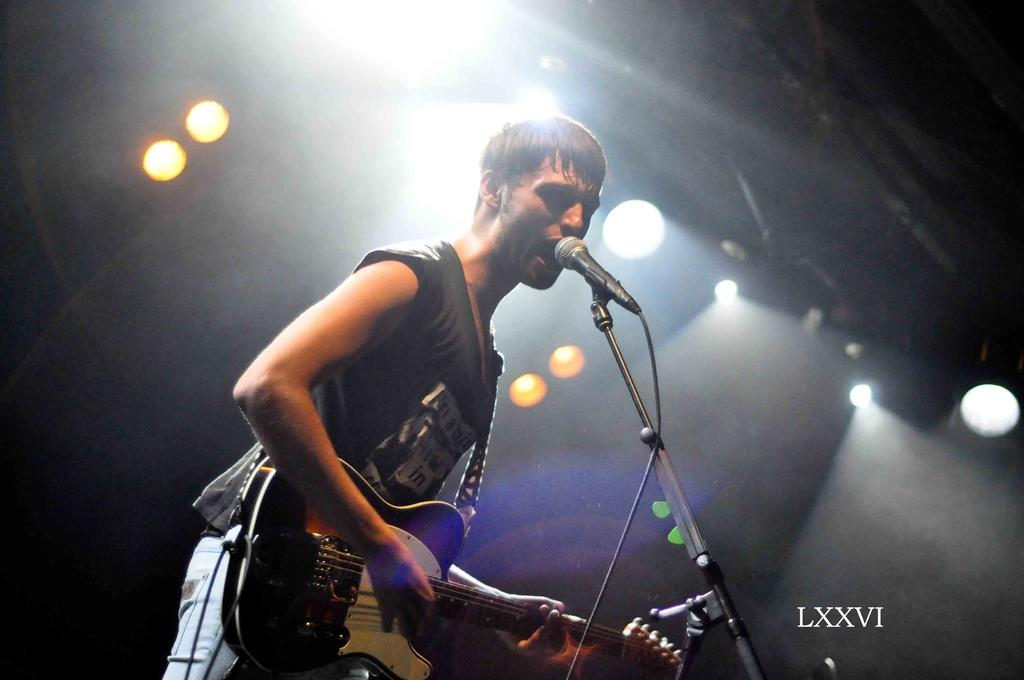What is the man in the image doing? The man is singing and playing a guitar. What is the man holding in the image? The man is holding a microphone. What can be seen in the background of the image? There are lights visible in the background of the image. What type of iron is being used to paint the canvas in the image? There is no iron or canvas present in the image. The man is singing and playing a guitar, and there are lights visible in the background. 